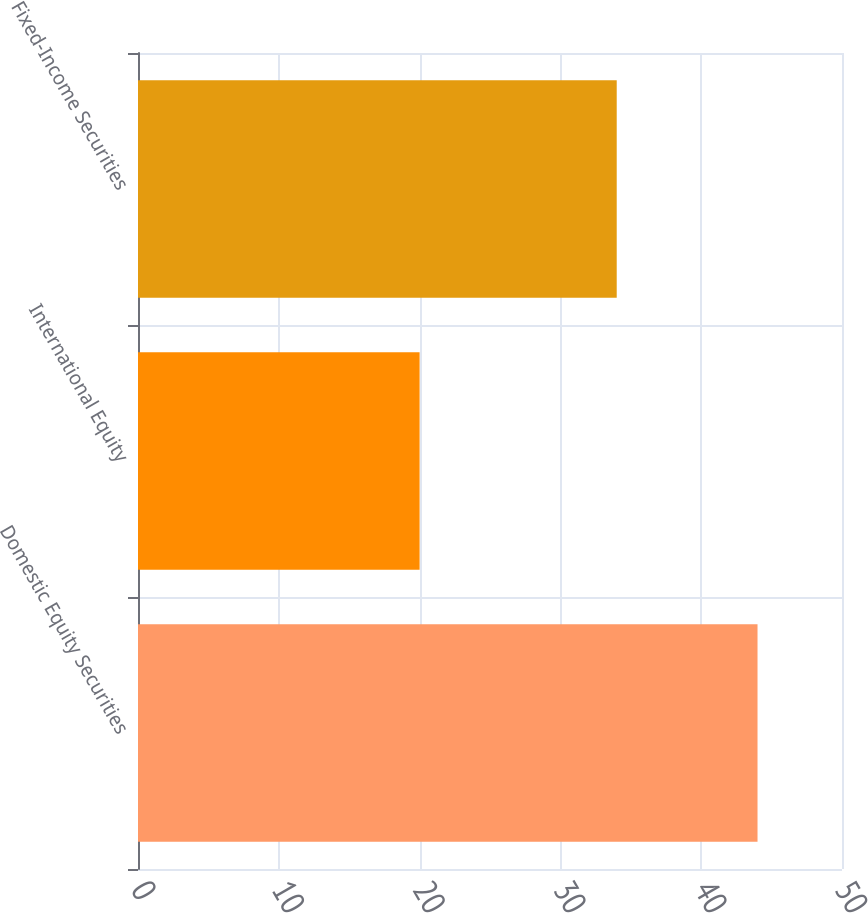Convert chart to OTSL. <chart><loc_0><loc_0><loc_500><loc_500><bar_chart><fcel>Domestic Equity Securities<fcel>International Equity<fcel>Fixed-Income Securities<nl><fcel>44<fcel>20<fcel>34<nl></chart> 